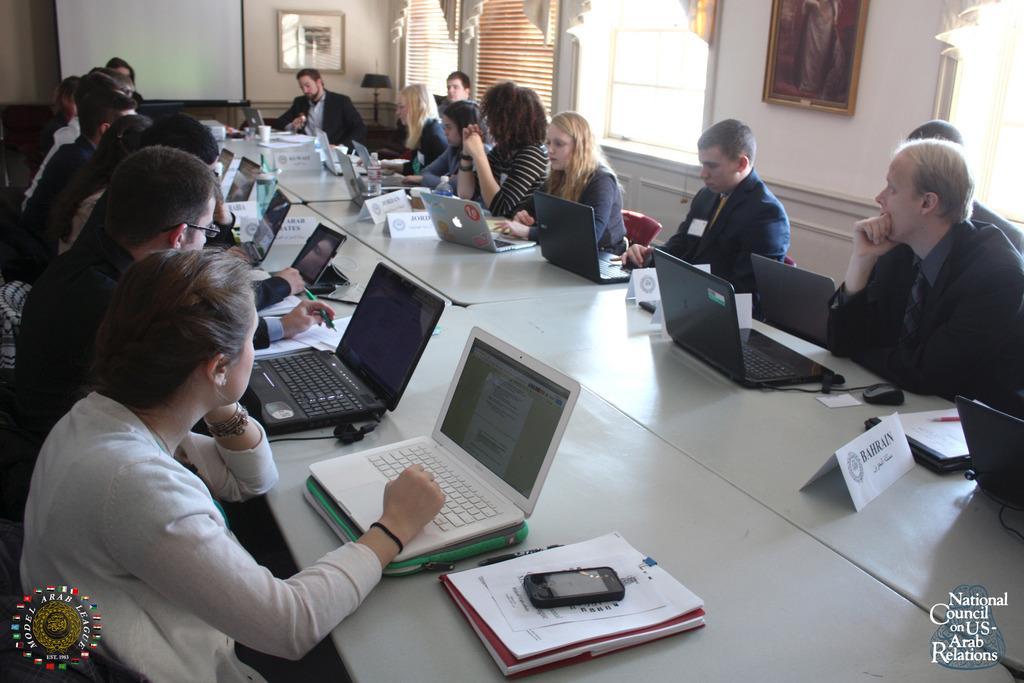Describe this image in one or two sentences. In this picture we can see a group of people, here we can see a table, on this table we can see laptops, mobile, papers, name boards, bottles, mouse, pens and in the background we can see the wall, photo frames, windows, curtains, in the bottom right and left we can see some text and a logo on it. 